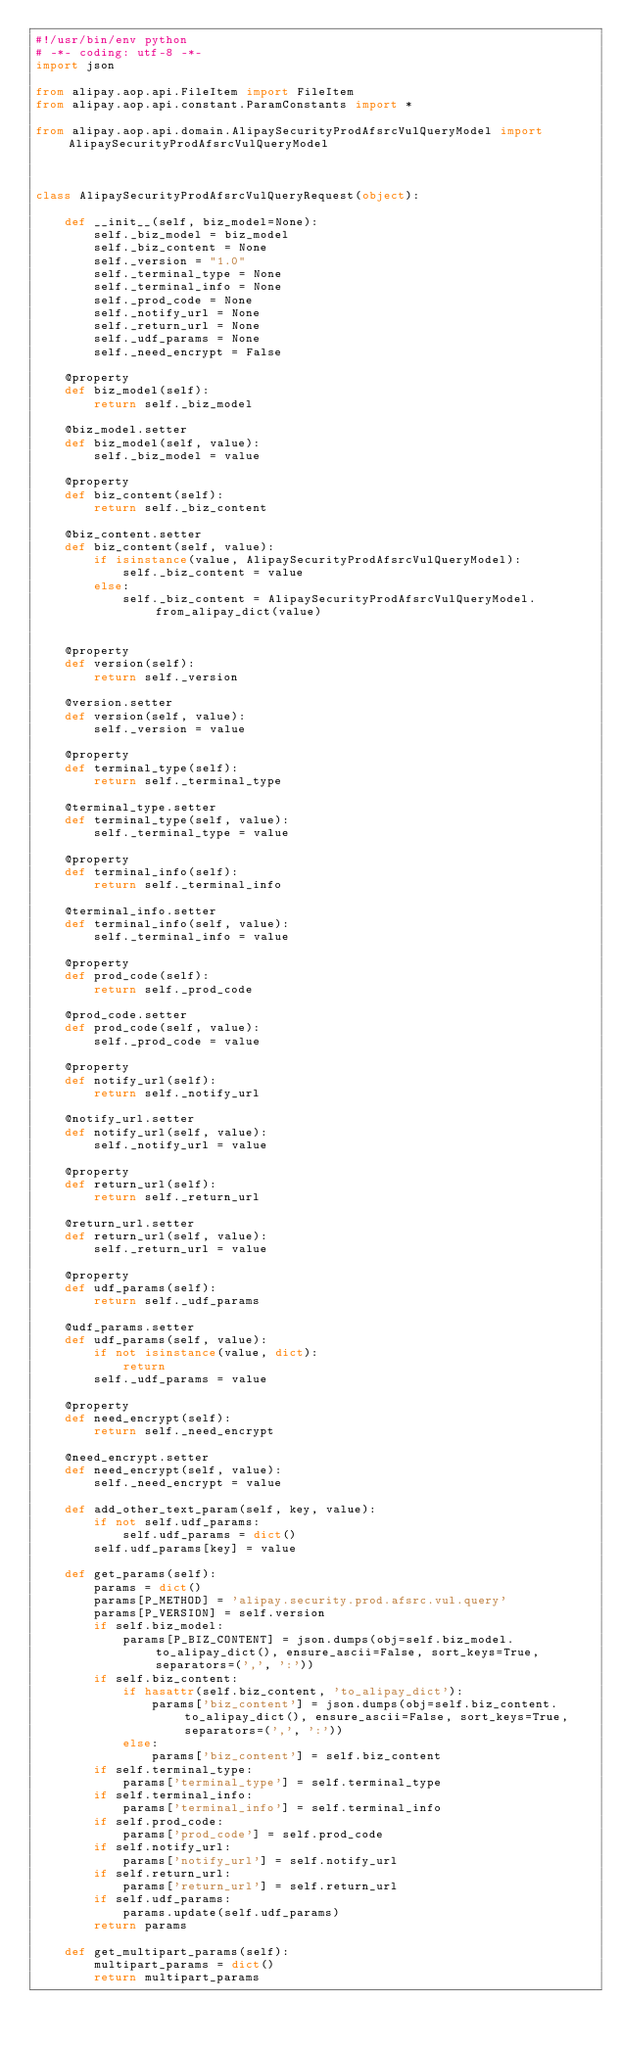Convert code to text. <code><loc_0><loc_0><loc_500><loc_500><_Python_>#!/usr/bin/env python
# -*- coding: utf-8 -*-
import json

from alipay.aop.api.FileItem import FileItem
from alipay.aop.api.constant.ParamConstants import *

from alipay.aop.api.domain.AlipaySecurityProdAfsrcVulQueryModel import AlipaySecurityProdAfsrcVulQueryModel



class AlipaySecurityProdAfsrcVulQueryRequest(object):

    def __init__(self, biz_model=None):
        self._biz_model = biz_model
        self._biz_content = None
        self._version = "1.0"
        self._terminal_type = None
        self._terminal_info = None
        self._prod_code = None
        self._notify_url = None
        self._return_url = None
        self._udf_params = None
        self._need_encrypt = False

    @property
    def biz_model(self):
        return self._biz_model

    @biz_model.setter
    def biz_model(self, value):
        self._biz_model = value

    @property
    def biz_content(self):
        return self._biz_content

    @biz_content.setter
    def biz_content(self, value):
        if isinstance(value, AlipaySecurityProdAfsrcVulQueryModel):
            self._biz_content = value
        else:
            self._biz_content = AlipaySecurityProdAfsrcVulQueryModel.from_alipay_dict(value)


    @property
    def version(self):
        return self._version

    @version.setter
    def version(self, value):
        self._version = value

    @property
    def terminal_type(self):
        return self._terminal_type

    @terminal_type.setter
    def terminal_type(self, value):
        self._terminal_type = value

    @property
    def terminal_info(self):
        return self._terminal_info

    @terminal_info.setter
    def terminal_info(self, value):
        self._terminal_info = value

    @property
    def prod_code(self):
        return self._prod_code

    @prod_code.setter
    def prod_code(self, value):
        self._prod_code = value

    @property
    def notify_url(self):
        return self._notify_url

    @notify_url.setter
    def notify_url(self, value):
        self._notify_url = value

    @property
    def return_url(self):
        return self._return_url

    @return_url.setter
    def return_url(self, value):
        self._return_url = value

    @property
    def udf_params(self):
        return self._udf_params

    @udf_params.setter
    def udf_params(self, value):
        if not isinstance(value, dict):
            return
        self._udf_params = value

    @property
    def need_encrypt(self):
        return self._need_encrypt

    @need_encrypt.setter
    def need_encrypt(self, value):
        self._need_encrypt = value

    def add_other_text_param(self, key, value):
        if not self.udf_params:
            self.udf_params = dict()
        self.udf_params[key] = value

    def get_params(self):
        params = dict()
        params[P_METHOD] = 'alipay.security.prod.afsrc.vul.query'
        params[P_VERSION] = self.version
        if self.biz_model:
            params[P_BIZ_CONTENT] = json.dumps(obj=self.biz_model.to_alipay_dict(), ensure_ascii=False, sort_keys=True, separators=(',', ':'))
        if self.biz_content:
            if hasattr(self.biz_content, 'to_alipay_dict'):
                params['biz_content'] = json.dumps(obj=self.biz_content.to_alipay_dict(), ensure_ascii=False, sort_keys=True, separators=(',', ':'))
            else:
                params['biz_content'] = self.biz_content
        if self.terminal_type:
            params['terminal_type'] = self.terminal_type
        if self.terminal_info:
            params['terminal_info'] = self.terminal_info
        if self.prod_code:
            params['prod_code'] = self.prod_code
        if self.notify_url:
            params['notify_url'] = self.notify_url
        if self.return_url:
            params['return_url'] = self.return_url
        if self.udf_params:
            params.update(self.udf_params)
        return params

    def get_multipart_params(self):
        multipart_params = dict()
        return multipart_params
</code> 